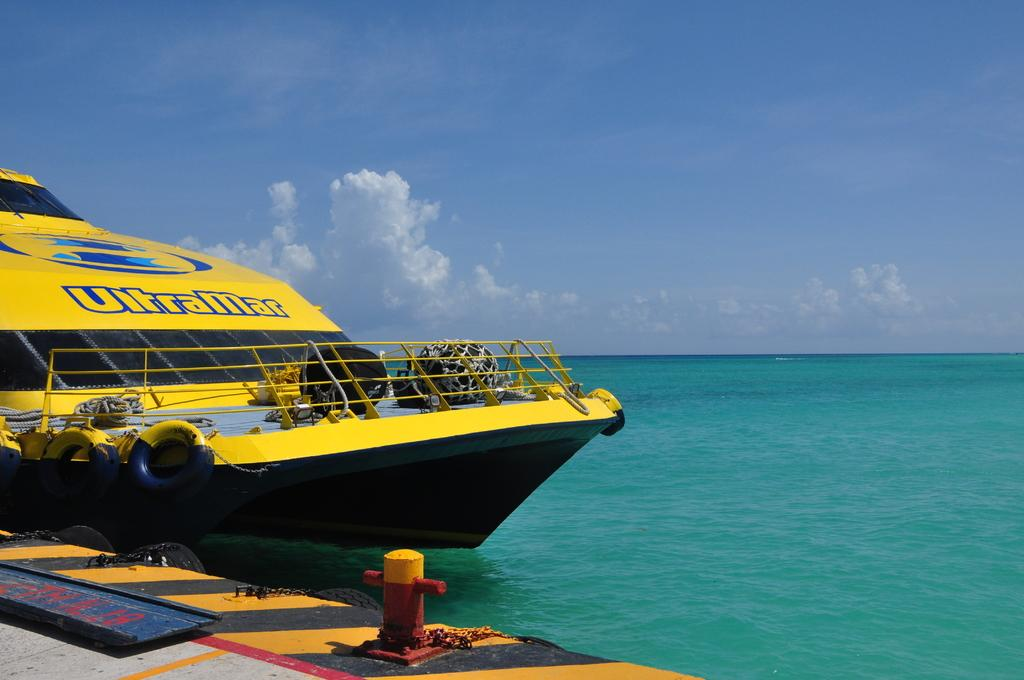What is the main subject of the image? The main subject of the image is a ship. Where is the ship located in the image? The ship is at the deck in the image. What objects can be seen on the ship? Chains are visible in the image. What natural elements are visible in the image? The sea and the sky are visible in the image. What is the condition of the sky in the image? Clouds are present in the sky in the image. What type of room can be seen in the image? There is no room present in the image; it features a ship at the deck with chains, the sea, and the sky visible. How does the ship move in the image? The image is a still representation, so the ship's movement cannot be determined. 